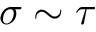<formula> <loc_0><loc_0><loc_500><loc_500>\sigma \sim \tau</formula> 